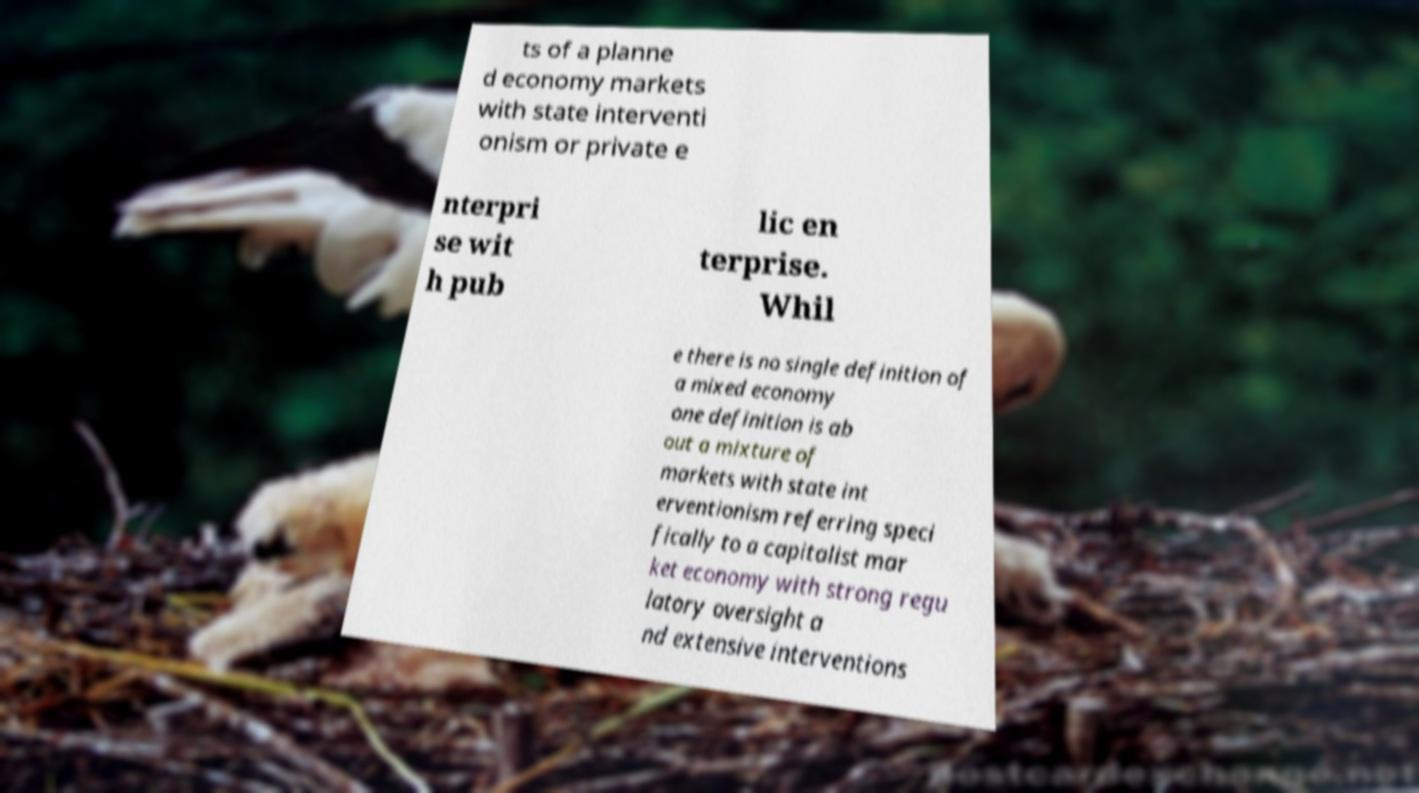Please read and relay the text visible in this image. What does it say? ts of a planne d economy markets with state interventi onism or private e nterpri se wit h pub lic en terprise. Whil e there is no single definition of a mixed economy one definition is ab out a mixture of markets with state int erventionism referring speci fically to a capitalist mar ket economy with strong regu latory oversight a nd extensive interventions 